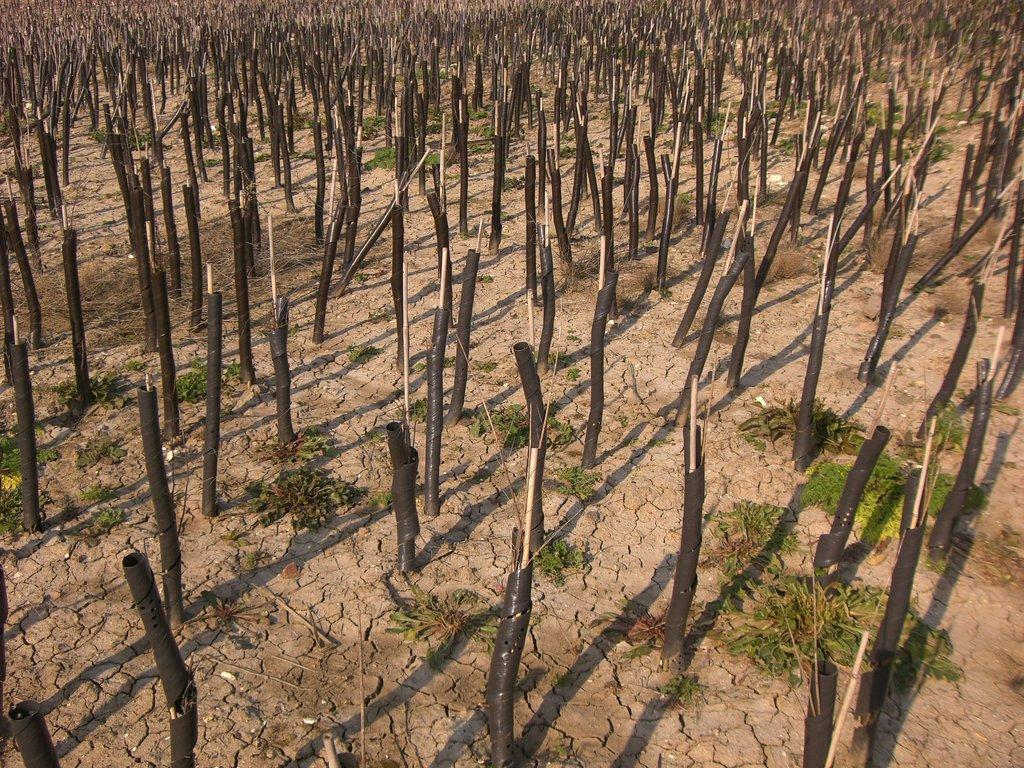What type of landscape is depicted in the image? There is a field in the image. What can be seen covering the field? The field is covered with stems. How does the cloth increase the value of the field in the image? There is no cloth present in the image, and therefore it cannot increase the value of the field. 